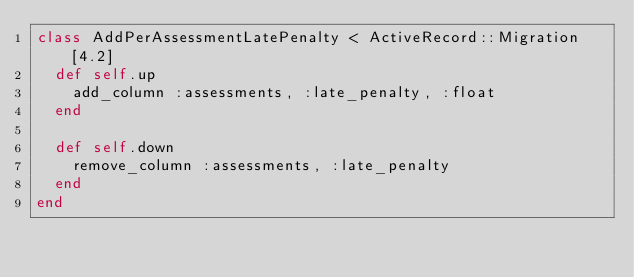<code> <loc_0><loc_0><loc_500><loc_500><_Ruby_>class AddPerAssessmentLatePenalty < ActiveRecord::Migration[4.2]
  def self.up
    add_column :assessments, :late_penalty, :float
  end

  def self.down
    remove_column :assessments, :late_penalty
  end
end
</code> 